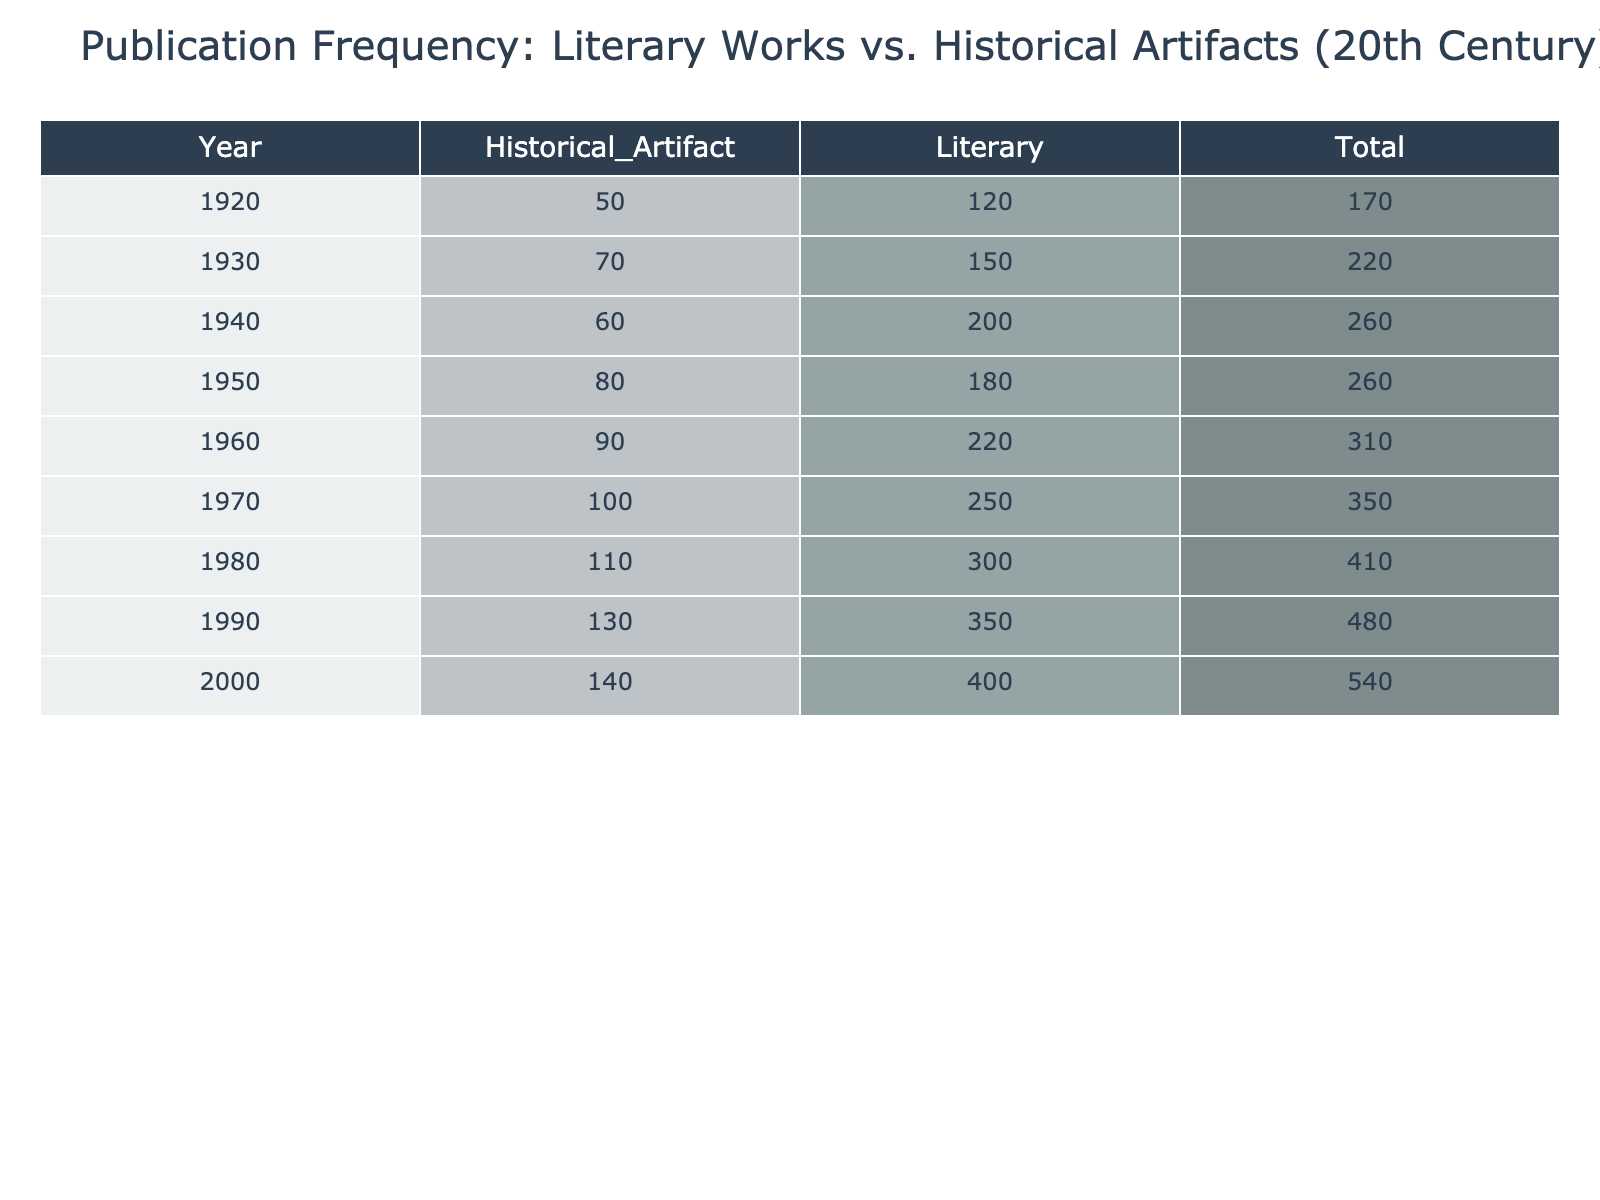What was the total count of literary works published in 1960? In the table, the count for literary works published in 1960 is given directly, which is 220.
Answer: 220 What is the total number of historical artifacts published in the decade from 1940 to 1950? To find the total number of historical artifacts published from 1940 to 1950, add the counts: 60 (1940) + 80 (1950) = 140.
Answer: 140 Did the number of literary works increase every decade from 1920 to 2000? By examining the counts for literary works in each decade, we see an increase every decade: 120 (1920), 150 (1930), 200 (1940), 180 (1950), 220 (1960), 250 (1970), 300 (1980), 350 (1990), 400 (2000). Therefore, the statement is true.
Answer: Yes What decade saw the highest publication of historical artifacts? By reviewing the counts for historical artifacts in every decade: 50 (1920), 70 (1930), 60 (1940), 80 (1950), 90 (1960), 100 (1970), 110 (1980), 130 (1990), 140 (2000), the highest count is 140 in the year 2000.
Answer: 2000 What is the average number of literary works published from 1930 to 1990? First, consider the counts for the years: 150 (1930), 200 (1940), 180 (1950), 220 (1960), 250 (1970), 300 (1980), 350 (1990). Adding these together gives 150 + 200 + 180 + 220 + 250 + 300 + 350 = 1650. Since there are 7 data points, the average is 1650/7 = approximately 235.71.
Answer: Approximately 235.71 By how much did the publication of historical artifacts change from 1920 to 2000? The count for historical artifacts in 1920 is 50 and in 2000 is 140. The change is 140 - 50 = 90.
Answer: 90 